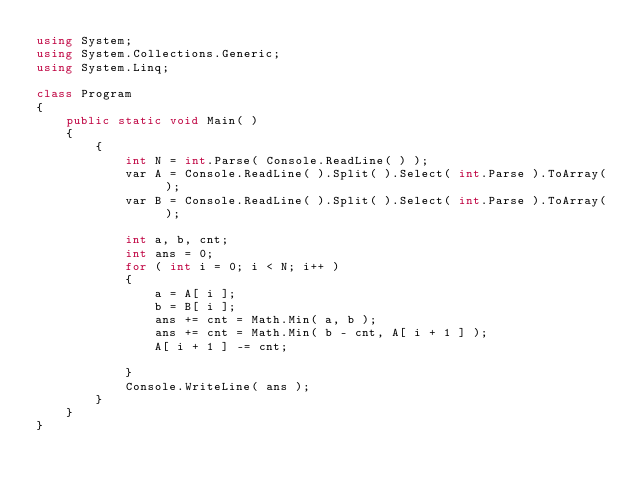Convert code to text. <code><loc_0><loc_0><loc_500><loc_500><_C#_>using System;
using System.Collections.Generic;
using System.Linq;

class Program
{
    public static void Main( )
    {
        {
            int N = int.Parse( Console.ReadLine( ) );
            var A = Console.ReadLine( ).Split( ).Select( int.Parse ).ToArray( );
            var B = Console.ReadLine( ).Split( ).Select( int.Parse ).ToArray( );

            int a, b, cnt;
            int ans = 0;
            for ( int i = 0; i < N; i++ )
            {
                a = A[ i ];
                b = B[ i ];
                ans += cnt = Math.Min( a, b );
                ans += cnt = Math.Min( b - cnt, A[ i + 1 ] );
                A[ i + 1 ] -= cnt;

            }
            Console.WriteLine( ans );
        }
    }
}

</code> 